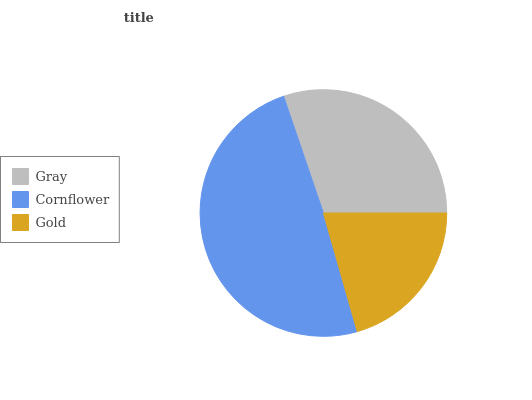Is Gold the minimum?
Answer yes or no. Yes. Is Cornflower the maximum?
Answer yes or no. Yes. Is Cornflower the minimum?
Answer yes or no. No. Is Gold the maximum?
Answer yes or no. No. Is Cornflower greater than Gold?
Answer yes or no. Yes. Is Gold less than Cornflower?
Answer yes or no. Yes. Is Gold greater than Cornflower?
Answer yes or no. No. Is Cornflower less than Gold?
Answer yes or no. No. Is Gray the high median?
Answer yes or no. Yes. Is Gray the low median?
Answer yes or no. Yes. Is Gold the high median?
Answer yes or no. No. Is Gold the low median?
Answer yes or no. No. 